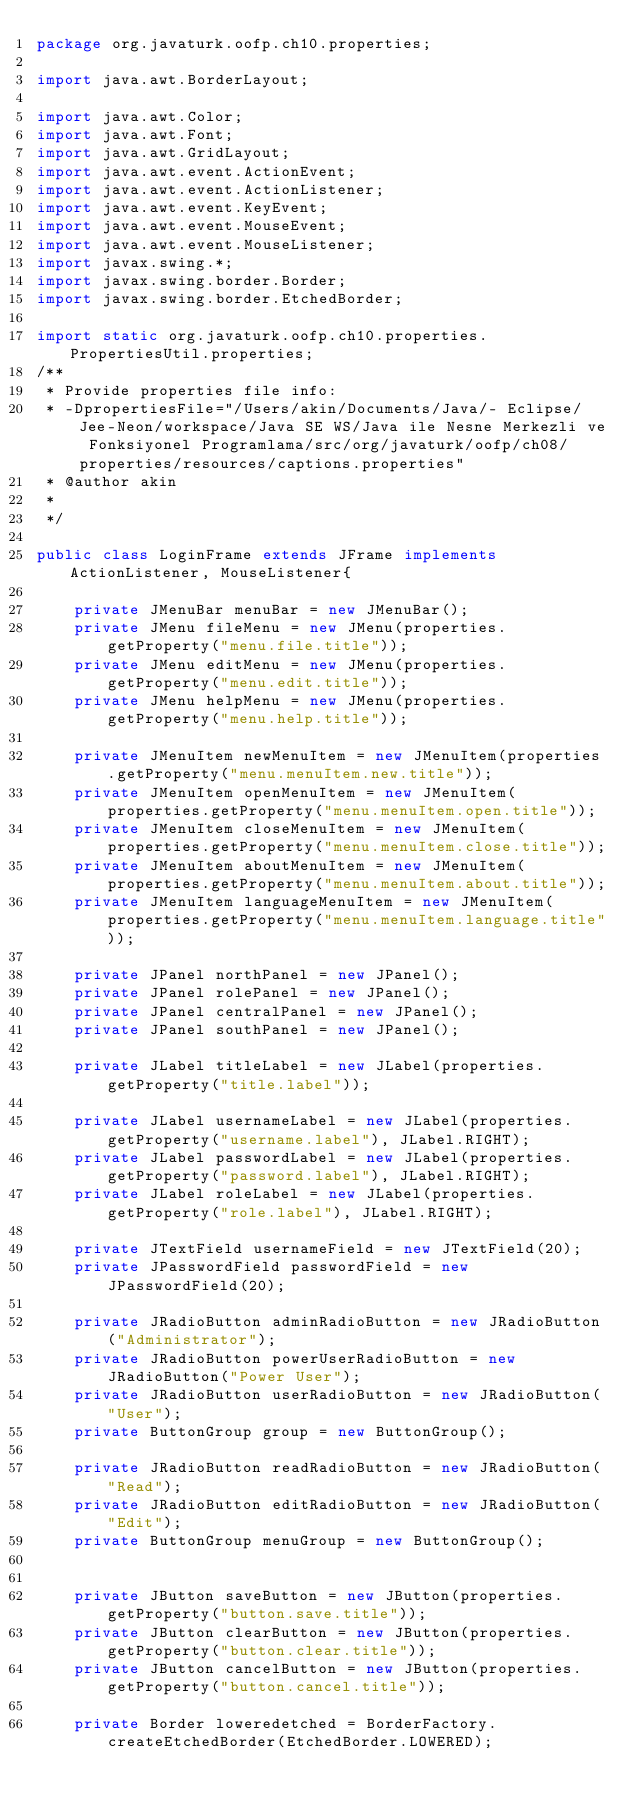Convert code to text. <code><loc_0><loc_0><loc_500><loc_500><_Java_>package org.javaturk.oofp.ch10.properties;

import java.awt.BorderLayout;

import java.awt.Color;
import java.awt.Font;
import java.awt.GridLayout;
import java.awt.event.ActionEvent;
import java.awt.event.ActionListener;
import java.awt.event.KeyEvent;
import java.awt.event.MouseEvent;
import java.awt.event.MouseListener;
import javax.swing.*;
import javax.swing.border.Border;
import javax.swing.border.EtchedBorder;

import static org.javaturk.oofp.ch10.properties.PropertiesUtil.properties;
/**
 * Provide properties file info:
 * -DpropertiesFile="/Users/akin/Documents/Java/- Eclipse/Jee-Neon/workspace/Java SE WS/Java ile Nesne Merkezli ve Fonksiyonel Programlama/src/org/javaturk/oofp/ch08/properties/resources/captions.properties"
 * @author akin
 *
 */

public class LoginFrame extends JFrame implements ActionListener, MouseListener{
	
	private JMenuBar menuBar = new JMenuBar();
	private JMenu fileMenu = new JMenu(properties.getProperty("menu.file.title"));
	private JMenu editMenu = new JMenu(properties.getProperty("menu.edit.title"));
	private JMenu helpMenu = new JMenu(properties.getProperty("menu.help.title"));
	
	private JMenuItem newMenuItem = new JMenuItem(properties.getProperty("menu.menuItem.new.title"));
	private JMenuItem openMenuItem = new JMenuItem(properties.getProperty("menu.menuItem.open.title"));
	private JMenuItem closeMenuItem = new JMenuItem(properties.getProperty("menu.menuItem.close.title"));
	private JMenuItem aboutMenuItem = new JMenuItem(properties.getProperty("menu.menuItem.about.title"));
	private JMenuItem languageMenuItem = new JMenuItem(properties.getProperty("menu.menuItem.language.title"));
	
	private JPanel northPanel = new JPanel();
	private JPanel rolePanel = new JPanel();
	private JPanel centralPanel = new JPanel();
	private JPanel southPanel = new JPanel();
	
	private JLabel titleLabel = new JLabel(properties.getProperty("title.label"));
	
	private JLabel usernameLabel = new JLabel(properties.getProperty("username.label"), JLabel.RIGHT);
	private JLabel passwordLabel = new JLabel(properties.getProperty("password.label"), JLabel.RIGHT);
	private JLabel roleLabel = new JLabel(properties.getProperty("role.label"), JLabel.RIGHT);
	
	private JTextField usernameField = new JTextField(20);
	private JPasswordField passwordField = new JPasswordField(20);
	
	private JRadioButton adminRadioButton = new JRadioButton("Administrator");
	private JRadioButton powerUserRadioButton = new JRadioButton("Power User");
	private JRadioButton userRadioButton = new JRadioButton("User");
	private ButtonGroup group = new ButtonGroup();
	
	private JRadioButton readRadioButton = new JRadioButton("Read");
	private JRadioButton editRadioButton = new JRadioButton("Edit");
	private ButtonGroup menuGroup = new ButtonGroup();

	
	private JButton saveButton = new JButton(properties.getProperty("button.save.title"));
	private JButton clearButton = new JButton(properties.getProperty("button.clear.title"));
	private JButton cancelButton = new JButton(properties.getProperty("button.cancel.title"));	
	
	private Border loweredetched = BorderFactory.createEtchedBorder(EtchedBorder.LOWERED);</code> 